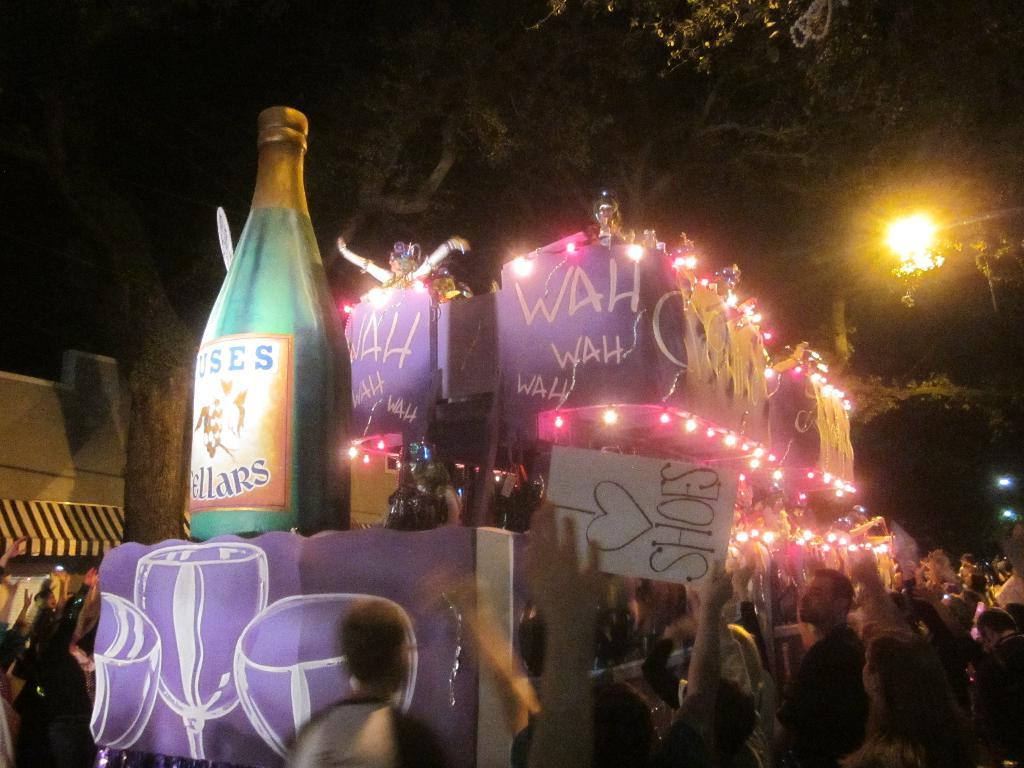How many people are in the image? There are persons in the image, but the exact number is not specified. What is the name board used for in the image? The name board is present in the image, but its purpose is not mentioned. What type of decorative items can be seen in the image? There are decorative items in the image, but their specific nature is not described. What type of trees are visible in the image? The type of trees is not specified in the provided facts. What are the other objects in the image? The other objects in the image are not described in detail. Where are the trees, lights, and other objects located in the image? Trees, lights, and other objects are visible at the top of the image. How many cobwebs can be seen hanging from the edge of the leg in the image? There is no mention of cobwebs, edges, or legs in the provided facts, so this question cannot be answered definitively. 